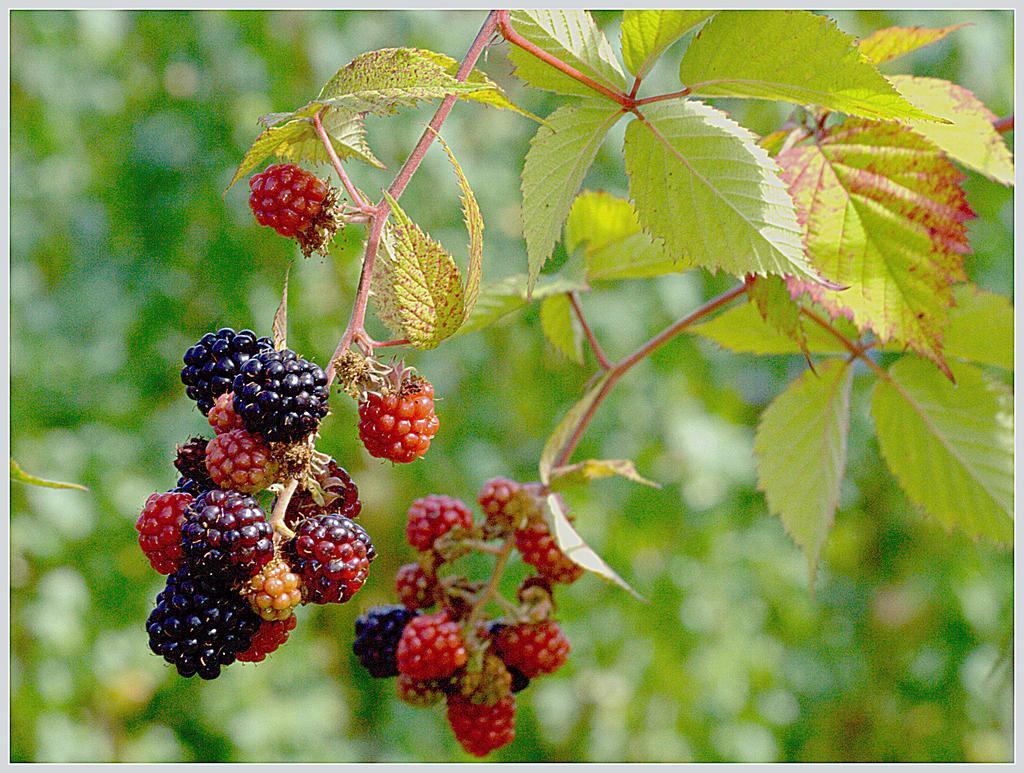Describe this image in one or two sentences. In this image in the foreground there are some berries which are hanging, and on the right side there is a plant. In the background there are some trees. 